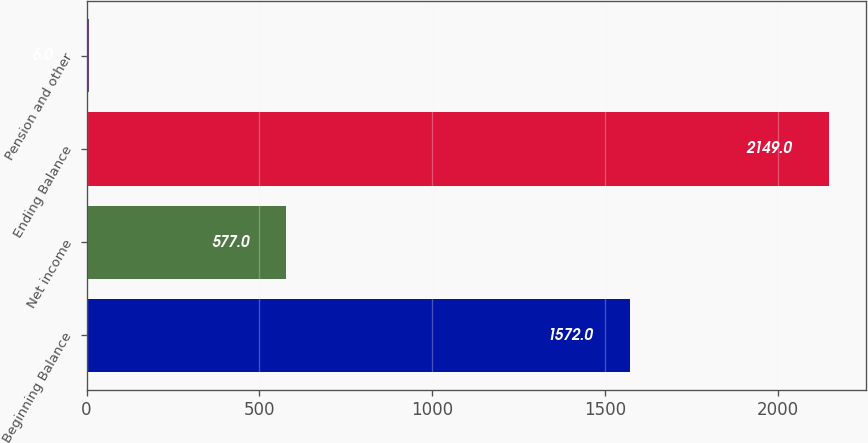Convert chart. <chart><loc_0><loc_0><loc_500><loc_500><bar_chart><fcel>Beginning Balance<fcel>Net income<fcel>Ending Balance<fcel>Pension and other<nl><fcel>1572<fcel>577<fcel>2149<fcel>6<nl></chart> 